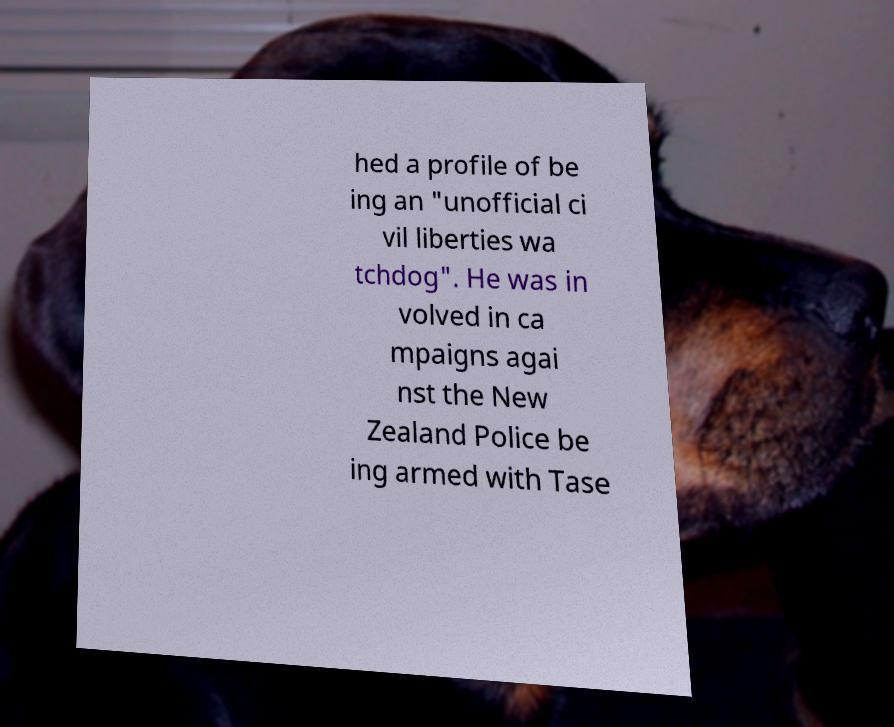For documentation purposes, I need the text within this image transcribed. Could you provide that? hed a profile of be ing an "unofficial ci vil liberties wa tchdog". He was in volved in ca mpaigns agai nst the New Zealand Police be ing armed with Tase 